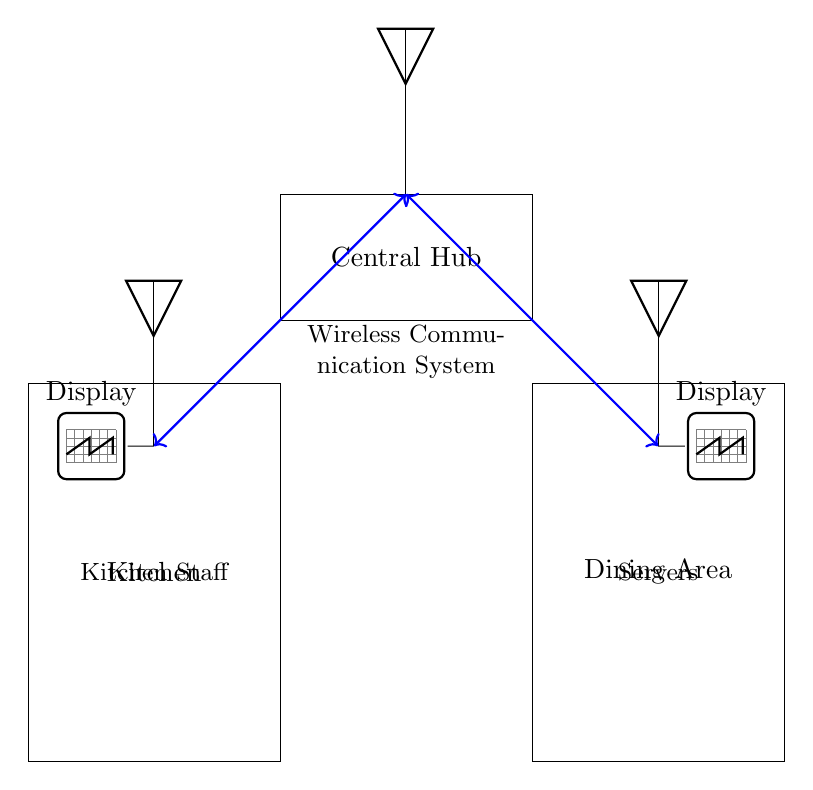What are the two main areas depicted in the diagram? The two main areas in the diagram are the Kitchen and the Dining Area, each represented by a rectangle.
Answer: Kitchen and Dining Area What does the central hub represent? The central hub in the diagram represents the main communication unit that coordinates the signals between the kitchen and dining area components.
Answer: Central Hub What type of connection is shown between the kitchen transmitter and the central hub? The connection is a wireless connection, indicated by the two-way arrow between the kitchen transmitter and the central hub's antenna.
Answer: Wireless How many displays are present in the circuit? There are two displays in the circuit, one in the kitchen and one in the dining area.
Answer: Two What is the function of the kitchen transmitter? The kitchen transmitter's function is to send communication signals from the kitchen staff to the central hub.
Answer: Send communication signals Which component receives signals in the dining area? The component that receives the signals in the dining area is the dining area receiver, represented by the antenna leading to the display.
Answer: Dining area receiver 